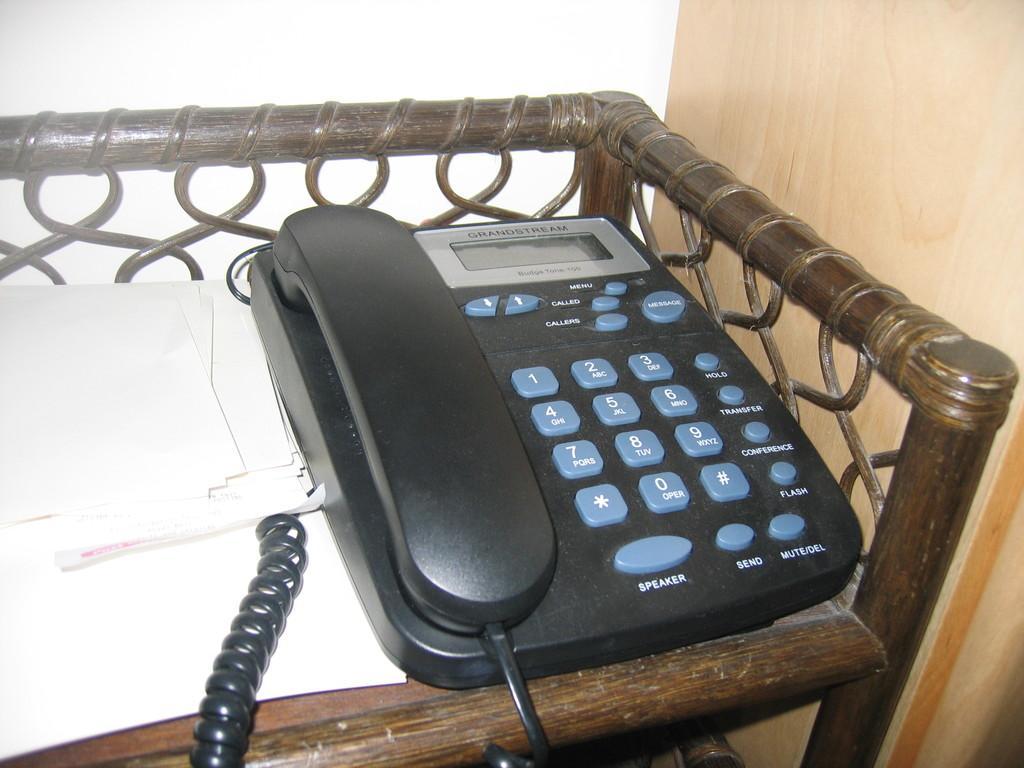Describe this image in one or two sentences. In this image, we can see a black color telephone, there are some white color papers beside the telephone, at the right side we can see wooden wall. 